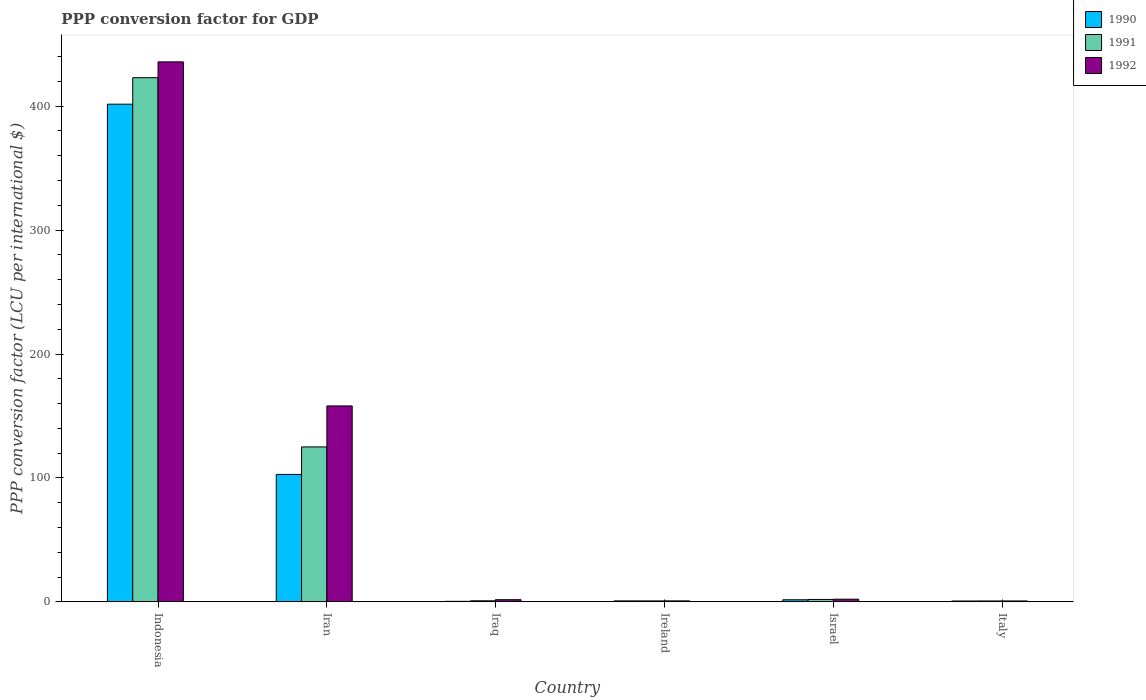How many different coloured bars are there?
Give a very brief answer. 3. How many groups of bars are there?
Give a very brief answer. 6. Are the number of bars per tick equal to the number of legend labels?
Your response must be concise. Yes. How many bars are there on the 2nd tick from the left?
Offer a very short reply. 3. How many bars are there on the 3rd tick from the right?
Ensure brevity in your answer.  3. In how many cases, is the number of bars for a given country not equal to the number of legend labels?
Give a very brief answer. 0. What is the PPP conversion factor for GDP in 1992 in Indonesia?
Your answer should be very brief. 435.74. Across all countries, what is the maximum PPP conversion factor for GDP in 1990?
Offer a very short reply. 401.61. Across all countries, what is the minimum PPP conversion factor for GDP in 1990?
Make the answer very short. 0.43. In which country was the PPP conversion factor for GDP in 1990 maximum?
Your answer should be very brief. Indonesia. What is the total PPP conversion factor for GDP in 1991 in the graph?
Provide a short and direct response. 552.39. What is the difference between the PPP conversion factor for GDP in 1990 in Iran and that in Iraq?
Offer a terse response. 102.42. What is the difference between the PPP conversion factor for GDP in 1992 in Iran and the PPP conversion factor for GDP in 1990 in Italy?
Keep it short and to the point. 157.41. What is the average PPP conversion factor for GDP in 1990 per country?
Offer a terse response. 84.68. What is the difference between the PPP conversion factor for GDP of/in 1992 and PPP conversion factor for GDP of/in 1990 in Iran?
Keep it short and to the point. 55.27. In how many countries, is the PPP conversion factor for GDP in 1991 greater than 220 LCU?
Offer a terse response. 1. What is the ratio of the PPP conversion factor for GDP in 1991 in Indonesia to that in Italy?
Offer a very short reply. 578.65. Is the PPP conversion factor for GDP in 1990 in Iraq less than that in Ireland?
Keep it short and to the point. Yes. Is the difference between the PPP conversion factor for GDP in 1992 in Iran and Israel greater than the difference between the PPP conversion factor for GDP in 1990 in Iran and Israel?
Your answer should be compact. Yes. What is the difference between the highest and the second highest PPP conversion factor for GDP in 1990?
Offer a terse response. 399.92. What is the difference between the highest and the lowest PPP conversion factor for GDP in 1991?
Keep it short and to the point. 422.26. What does the 2nd bar from the left in Israel represents?
Provide a succinct answer. 1991. What does the 1st bar from the right in Italy represents?
Your answer should be very brief. 1992. How many bars are there?
Make the answer very short. 18. Are all the bars in the graph horizontal?
Your answer should be very brief. No. Are the values on the major ticks of Y-axis written in scientific E-notation?
Provide a short and direct response. No. Does the graph contain any zero values?
Ensure brevity in your answer.  No. How many legend labels are there?
Make the answer very short. 3. How are the legend labels stacked?
Your answer should be very brief. Vertical. What is the title of the graph?
Your answer should be compact. PPP conversion factor for GDP. What is the label or title of the X-axis?
Offer a terse response. Country. What is the label or title of the Y-axis?
Your answer should be compact. PPP conversion factor (LCU per international $). What is the PPP conversion factor (LCU per international $) of 1990 in Indonesia?
Provide a short and direct response. 401.61. What is the PPP conversion factor (LCU per international $) of 1991 in Indonesia?
Provide a succinct answer. 422.99. What is the PPP conversion factor (LCU per international $) of 1992 in Indonesia?
Provide a succinct answer. 435.74. What is the PPP conversion factor (LCU per international $) of 1990 in Iran?
Offer a terse response. 102.85. What is the PPP conversion factor (LCU per international $) in 1991 in Iran?
Your answer should be very brief. 125.03. What is the PPP conversion factor (LCU per international $) of 1992 in Iran?
Provide a short and direct response. 158.12. What is the PPP conversion factor (LCU per international $) in 1990 in Iraq?
Your answer should be very brief. 0.43. What is the PPP conversion factor (LCU per international $) of 1991 in Iraq?
Keep it short and to the point. 0.88. What is the PPP conversion factor (LCU per international $) of 1992 in Iraq?
Your answer should be very brief. 1.76. What is the PPP conversion factor (LCU per international $) in 1990 in Ireland?
Ensure brevity in your answer.  0.8. What is the PPP conversion factor (LCU per international $) in 1991 in Ireland?
Your answer should be compact. 0.79. What is the PPP conversion factor (LCU per international $) in 1992 in Ireland?
Your answer should be compact. 0.8. What is the PPP conversion factor (LCU per international $) of 1990 in Israel?
Your answer should be very brief. 1.69. What is the PPP conversion factor (LCU per international $) of 1991 in Israel?
Make the answer very short. 1.97. What is the PPP conversion factor (LCU per international $) in 1992 in Israel?
Keep it short and to the point. 2.15. What is the PPP conversion factor (LCU per international $) in 1990 in Italy?
Offer a terse response. 0.7. What is the PPP conversion factor (LCU per international $) in 1991 in Italy?
Keep it short and to the point. 0.73. What is the PPP conversion factor (LCU per international $) of 1992 in Italy?
Offer a terse response. 0.75. Across all countries, what is the maximum PPP conversion factor (LCU per international $) of 1990?
Provide a succinct answer. 401.61. Across all countries, what is the maximum PPP conversion factor (LCU per international $) of 1991?
Offer a very short reply. 422.99. Across all countries, what is the maximum PPP conversion factor (LCU per international $) of 1992?
Offer a terse response. 435.74. Across all countries, what is the minimum PPP conversion factor (LCU per international $) of 1990?
Provide a succinct answer. 0.43. Across all countries, what is the minimum PPP conversion factor (LCU per international $) of 1991?
Your response must be concise. 0.73. Across all countries, what is the minimum PPP conversion factor (LCU per international $) of 1992?
Offer a terse response. 0.75. What is the total PPP conversion factor (LCU per international $) in 1990 in the graph?
Give a very brief answer. 508.09. What is the total PPP conversion factor (LCU per international $) of 1991 in the graph?
Ensure brevity in your answer.  552.39. What is the total PPP conversion factor (LCU per international $) in 1992 in the graph?
Give a very brief answer. 599.31. What is the difference between the PPP conversion factor (LCU per international $) in 1990 in Indonesia and that in Iran?
Your answer should be compact. 298.77. What is the difference between the PPP conversion factor (LCU per international $) in 1991 in Indonesia and that in Iran?
Your answer should be very brief. 297.95. What is the difference between the PPP conversion factor (LCU per international $) in 1992 in Indonesia and that in Iran?
Provide a succinct answer. 277.63. What is the difference between the PPP conversion factor (LCU per international $) in 1990 in Indonesia and that in Iraq?
Your answer should be compact. 401.18. What is the difference between the PPP conversion factor (LCU per international $) of 1991 in Indonesia and that in Iraq?
Provide a succinct answer. 422.11. What is the difference between the PPP conversion factor (LCU per international $) in 1992 in Indonesia and that in Iraq?
Give a very brief answer. 433.99. What is the difference between the PPP conversion factor (LCU per international $) in 1990 in Indonesia and that in Ireland?
Offer a very short reply. 400.81. What is the difference between the PPP conversion factor (LCU per international $) of 1991 in Indonesia and that in Ireland?
Provide a short and direct response. 422.19. What is the difference between the PPP conversion factor (LCU per international $) of 1992 in Indonesia and that in Ireland?
Offer a very short reply. 434.95. What is the difference between the PPP conversion factor (LCU per international $) in 1990 in Indonesia and that in Israel?
Provide a short and direct response. 399.92. What is the difference between the PPP conversion factor (LCU per international $) of 1991 in Indonesia and that in Israel?
Give a very brief answer. 421.02. What is the difference between the PPP conversion factor (LCU per international $) in 1992 in Indonesia and that in Israel?
Give a very brief answer. 433.59. What is the difference between the PPP conversion factor (LCU per international $) of 1990 in Indonesia and that in Italy?
Offer a very short reply. 400.91. What is the difference between the PPP conversion factor (LCU per international $) of 1991 in Indonesia and that in Italy?
Provide a short and direct response. 422.26. What is the difference between the PPP conversion factor (LCU per international $) of 1992 in Indonesia and that in Italy?
Your answer should be very brief. 435. What is the difference between the PPP conversion factor (LCU per international $) in 1990 in Iran and that in Iraq?
Offer a very short reply. 102.42. What is the difference between the PPP conversion factor (LCU per international $) in 1991 in Iran and that in Iraq?
Offer a very short reply. 124.15. What is the difference between the PPP conversion factor (LCU per international $) of 1992 in Iran and that in Iraq?
Your answer should be very brief. 156.36. What is the difference between the PPP conversion factor (LCU per international $) of 1990 in Iran and that in Ireland?
Your answer should be compact. 102.04. What is the difference between the PPP conversion factor (LCU per international $) of 1991 in Iran and that in Ireland?
Provide a succinct answer. 124.24. What is the difference between the PPP conversion factor (LCU per international $) in 1992 in Iran and that in Ireland?
Ensure brevity in your answer.  157.32. What is the difference between the PPP conversion factor (LCU per international $) in 1990 in Iran and that in Israel?
Your answer should be compact. 101.16. What is the difference between the PPP conversion factor (LCU per international $) of 1991 in Iran and that in Israel?
Give a very brief answer. 123.07. What is the difference between the PPP conversion factor (LCU per international $) in 1992 in Iran and that in Israel?
Make the answer very short. 155.96. What is the difference between the PPP conversion factor (LCU per international $) in 1990 in Iran and that in Italy?
Make the answer very short. 102.15. What is the difference between the PPP conversion factor (LCU per international $) in 1991 in Iran and that in Italy?
Offer a terse response. 124.3. What is the difference between the PPP conversion factor (LCU per international $) in 1992 in Iran and that in Italy?
Offer a terse response. 157.37. What is the difference between the PPP conversion factor (LCU per international $) in 1990 in Iraq and that in Ireland?
Offer a very short reply. -0.37. What is the difference between the PPP conversion factor (LCU per international $) in 1991 in Iraq and that in Ireland?
Keep it short and to the point. 0.09. What is the difference between the PPP conversion factor (LCU per international $) of 1992 in Iraq and that in Ireland?
Provide a succinct answer. 0.96. What is the difference between the PPP conversion factor (LCU per international $) in 1990 in Iraq and that in Israel?
Keep it short and to the point. -1.26. What is the difference between the PPP conversion factor (LCU per international $) of 1991 in Iraq and that in Israel?
Provide a short and direct response. -1.09. What is the difference between the PPP conversion factor (LCU per international $) in 1992 in Iraq and that in Israel?
Ensure brevity in your answer.  -0.4. What is the difference between the PPP conversion factor (LCU per international $) of 1990 in Iraq and that in Italy?
Make the answer very short. -0.27. What is the difference between the PPP conversion factor (LCU per international $) of 1991 in Iraq and that in Italy?
Your answer should be very brief. 0.15. What is the difference between the PPP conversion factor (LCU per international $) in 1992 in Iraq and that in Italy?
Keep it short and to the point. 1.01. What is the difference between the PPP conversion factor (LCU per international $) of 1990 in Ireland and that in Israel?
Offer a very short reply. -0.89. What is the difference between the PPP conversion factor (LCU per international $) in 1991 in Ireland and that in Israel?
Keep it short and to the point. -1.17. What is the difference between the PPP conversion factor (LCU per international $) of 1992 in Ireland and that in Israel?
Provide a short and direct response. -1.36. What is the difference between the PPP conversion factor (LCU per international $) of 1990 in Ireland and that in Italy?
Offer a terse response. 0.1. What is the difference between the PPP conversion factor (LCU per international $) of 1991 in Ireland and that in Italy?
Keep it short and to the point. 0.06. What is the difference between the PPP conversion factor (LCU per international $) of 1992 in Ireland and that in Italy?
Provide a succinct answer. 0.05. What is the difference between the PPP conversion factor (LCU per international $) in 1990 in Israel and that in Italy?
Keep it short and to the point. 0.99. What is the difference between the PPP conversion factor (LCU per international $) of 1991 in Israel and that in Italy?
Provide a short and direct response. 1.23. What is the difference between the PPP conversion factor (LCU per international $) of 1992 in Israel and that in Italy?
Offer a very short reply. 1.41. What is the difference between the PPP conversion factor (LCU per international $) in 1990 in Indonesia and the PPP conversion factor (LCU per international $) in 1991 in Iran?
Keep it short and to the point. 276.58. What is the difference between the PPP conversion factor (LCU per international $) of 1990 in Indonesia and the PPP conversion factor (LCU per international $) of 1992 in Iran?
Your answer should be compact. 243.5. What is the difference between the PPP conversion factor (LCU per international $) in 1991 in Indonesia and the PPP conversion factor (LCU per international $) in 1992 in Iran?
Give a very brief answer. 264.87. What is the difference between the PPP conversion factor (LCU per international $) of 1990 in Indonesia and the PPP conversion factor (LCU per international $) of 1991 in Iraq?
Provide a short and direct response. 400.74. What is the difference between the PPP conversion factor (LCU per international $) of 1990 in Indonesia and the PPP conversion factor (LCU per international $) of 1992 in Iraq?
Offer a very short reply. 399.86. What is the difference between the PPP conversion factor (LCU per international $) in 1991 in Indonesia and the PPP conversion factor (LCU per international $) in 1992 in Iraq?
Offer a terse response. 421.23. What is the difference between the PPP conversion factor (LCU per international $) of 1990 in Indonesia and the PPP conversion factor (LCU per international $) of 1991 in Ireland?
Make the answer very short. 400.82. What is the difference between the PPP conversion factor (LCU per international $) in 1990 in Indonesia and the PPP conversion factor (LCU per international $) in 1992 in Ireland?
Provide a short and direct response. 400.82. What is the difference between the PPP conversion factor (LCU per international $) in 1991 in Indonesia and the PPP conversion factor (LCU per international $) in 1992 in Ireland?
Give a very brief answer. 422.19. What is the difference between the PPP conversion factor (LCU per international $) in 1990 in Indonesia and the PPP conversion factor (LCU per international $) in 1991 in Israel?
Your answer should be very brief. 399.65. What is the difference between the PPP conversion factor (LCU per international $) of 1990 in Indonesia and the PPP conversion factor (LCU per international $) of 1992 in Israel?
Your answer should be very brief. 399.46. What is the difference between the PPP conversion factor (LCU per international $) of 1991 in Indonesia and the PPP conversion factor (LCU per international $) of 1992 in Israel?
Your answer should be very brief. 420.83. What is the difference between the PPP conversion factor (LCU per international $) of 1990 in Indonesia and the PPP conversion factor (LCU per international $) of 1991 in Italy?
Your answer should be compact. 400.88. What is the difference between the PPP conversion factor (LCU per international $) of 1990 in Indonesia and the PPP conversion factor (LCU per international $) of 1992 in Italy?
Your response must be concise. 400.87. What is the difference between the PPP conversion factor (LCU per international $) of 1991 in Indonesia and the PPP conversion factor (LCU per international $) of 1992 in Italy?
Your answer should be compact. 422.24. What is the difference between the PPP conversion factor (LCU per international $) in 1990 in Iran and the PPP conversion factor (LCU per international $) in 1991 in Iraq?
Your answer should be compact. 101.97. What is the difference between the PPP conversion factor (LCU per international $) of 1990 in Iran and the PPP conversion factor (LCU per international $) of 1992 in Iraq?
Give a very brief answer. 101.09. What is the difference between the PPP conversion factor (LCU per international $) in 1991 in Iran and the PPP conversion factor (LCU per international $) in 1992 in Iraq?
Your answer should be very brief. 123.28. What is the difference between the PPP conversion factor (LCU per international $) of 1990 in Iran and the PPP conversion factor (LCU per international $) of 1991 in Ireland?
Your answer should be compact. 102.06. What is the difference between the PPP conversion factor (LCU per international $) in 1990 in Iran and the PPP conversion factor (LCU per international $) in 1992 in Ireland?
Provide a short and direct response. 102.05. What is the difference between the PPP conversion factor (LCU per international $) of 1991 in Iran and the PPP conversion factor (LCU per international $) of 1992 in Ireland?
Give a very brief answer. 124.24. What is the difference between the PPP conversion factor (LCU per international $) of 1990 in Iran and the PPP conversion factor (LCU per international $) of 1991 in Israel?
Offer a terse response. 100.88. What is the difference between the PPP conversion factor (LCU per international $) in 1990 in Iran and the PPP conversion factor (LCU per international $) in 1992 in Israel?
Your answer should be compact. 100.69. What is the difference between the PPP conversion factor (LCU per international $) of 1991 in Iran and the PPP conversion factor (LCU per international $) of 1992 in Israel?
Make the answer very short. 122.88. What is the difference between the PPP conversion factor (LCU per international $) in 1990 in Iran and the PPP conversion factor (LCU per international $) in 1991 in Italy?
Your answer should be very brief. 102.12. What is the difference between the PPP conversion factor (LCU per international $) of 1990 in Iran and the PPP conversion factor (LCU per international $) of 1992 in Italy?
Your answer should be compact. 102.1. What is the difference between the PPP conversion factor (LCU per international $) in 1991 in Iran and the PPP conversion factor (LCU per international $) in 1992 in Italy?
Provide a succinct answer. 124.29. What is the difference between the PPP conversion factor (LCU per international $) of 1990 in Iraq and the PPP conversion factor (LCU per international $) of 1991 in Ireland?
Your response must be concise. -0.36. What is the difference between the PPP conversion factor (LCU per international $) of 1990 in Iraq and the PPP conversion factor (LCU per international $) of 1992 in Ireland?
Keep it short and to the point. -0.37. What is the difference between the PPP conversion factor (LCU per international $) in 1991 in Iraq and the PPP conversion factor (LCU per international $) in 1992 in Ireland?
Your answer should be very brief. 0.08. What is the difference between the PPP conversion factor (LCU per international $) of 1990 in Iraq and the PPP conversion factor (LCU per international $) of 1991 in Israel?
Your answer should be very brief. -1.54. What is the difference between the PPP conversion factor (LCU per international $) of 1990 in Iraq and the PPP conversion factor (LCU per international $) of 1992 in Israel?
Your answer should be compact. -1.72. What is the difference between the PPP conversion factor (LCU per international $) of 1991 in Iraq and the PPP conversion factor (LCU per international $) of 1992 in Israel?
Offer a terse response. -1.27. What is the difference between the PPP conversion factor (LCU per international $) in 1990 in Iraq and the PPP conversion factor (LCU per international $) in 1991 in Italy?
Your answer should be compact. -0.3. What is the difference between the PPP conversion factor (LCU per international $) of 1990 in Iraq and the PPP conversion factor (LCU per international $) of 1992 in Italy?
Provide a short and direct response. -0.32. What is the difference between the PPP conversion factor (LCU per international $) of 1991 in Iraq and the PPP conversion factor (LCU per international $) of 1992 in Italy?
Your answer should be very brief. 0.13. What is the difference between the PPP conversion factor (LCU per international $) in 1990 in Ireland and the PPP conversion factor (LCU per international $) in 1991 in Israel?
Your response must be concise. -1.16. What is the difference between the PPP conversion factor (LCU per international $) in 1990 in Ireland and the PPP conversion factor (LCU per international $) in 1992 in Israel?
Provide a short and direct response. -1.35. What is the difference between the PPP conversion factor (LCU per international $) in 1991 in Ireland and the PPP conversion factor (LCU per international $) in 1992 in Israel?
Provide a succinct answer. -1.36. What is the difference between the PPP conversion factor (LCU per international $) of 1990 in Ireland and the PPP conversion factor (LCU per international $) of 1991 in Italy?
Give a very brief answer. 0.07. What is the difference between the PPP conversion factor (LCU per international $) of 1990 in Ireland and the PPP conversion factor (LCU per international $) of 1992 in Italy?
Your answer should be very brief. 0.06. What is the difference between the PPP conversion factor (LCU per international $) in 1991 in Ireland and the PPP conversion factor (LCU per international $) in 1992 in Italy?
Provide a succinct answer. 0.05. What is the difference between the PPP conversion factor (LCU per international $) of 1990 in Israel and the PPP conversion factor (LCU per international $) of 1991 in Italy?
Keep it short and to the point. 0.96. What is the difference between the PPP conversion factor (LCU per international $) of 1990 in Israel and the PPP conversion factor (LCU per international $) of 1992 in Italy?
Offer a terse response. 0.94. What is the difference between the PPP conversion factor (LCU per international $) of 1991 in Israel and the PPP conversion factor (LCU per international $) of 1992 in Italy?
Provide a short and direct response. 1.22. What is the average PPP conversion factor (LCU per international $) of 1990 per country?
Offer a terse response. 84.68. What is the average PPP conversion factor (LCU per international $) in 1991 per country?
Provide a succinct answer. 92.06. What is the average PPP conversion factor (LCU per international $) in 1992 per country?
Keep it short and to the point. 99.89. What is the difference between the PPP conversion factor (LCU per international $) of 1990 and PPP conversion factor (LCU per international $) of 1991 in Indonesia?
Your response must be concise. -21.37. What is the difference between the PPP conversion factor (LCU per international $) of 1990 and PPP conversion factor (LCU per international $) of 1992 in Indonesia?
Offer a terse response. -34.13. What is the difference between the PPP conversion factor (LCU per international $) in 1991 and PPP conversion factor (LCU per international $) in 1992 in Indonesia?
Your response must be concise. -12.76. What is the difference between the PPP conversion factor (LCU per international $) of 1990 and PPP conversion factor (LCU per international $) of 1991 in Iran?
Offer a terse response. -22.18. What is the difference between the PPP conversion factor (LCU per international $) of 1990 and PPP conversion factor (LCU per international $) of 1992 in Iran?
Make the answer very short. -55.27. What is the difference between the PPP conversion factor (LCU per international $) in 1991 and PPP conversion factor (LCU per international $) in 1992 in Iran?
Your answer should be compact. -33.08. What is the difference between the PPP conversion factor (LCU per international $) in 1990 and PPP conversion factor (LCU per international $) in 1991 in Iraq?
Provide a short and direct response. -0.45. What is the difference between the PPP conversion factor (LCU per international $) of 1990 and PPP conversion factor (LCU per international $) of 1992 in Iraq?
Make the answer very short. -1.33. What is the difference between the PPP conversion factor (LCU per international $) in 1991 and PPP conversion factor (LCU per international $) in 1992 in Iraq?
Keep it short and to the point. -0.88. What is the difference between the PPP conversion factor (LCU per international $) of 1990 and PPP conversion factor (LCU per international $) of 1991 in Ireland?
Ensure brevity in your answer.  0.01. What is the difference between the PPP conversion factor (LCU per international $) of 1990 and PPP conversion factor (LCU per international $) of 1992 in Ireland?
Ensure brevity in your answer.  0.01. What is the difference between the PPP conversion factor (LCU per international $) of 1991 and PPP conversion factor (LCU per international $) of 1992 in Ireland?
Make the answer very short. -0. What is the difference between the PPP conversion factor (LCU per international $) in 1990 and PPP conversion factor (LCU per international $) in 1991 in Israel?
Offer a terse response. -0.27. What is the difference between the PPP conversion factor (LCU per international $) of 1990 and PPP conversion factor (LCU per international $) of 1992 in Israel?
Make the answer very short. -0.46. What is the difference between the PPP conversion factor (LCU per international $) in 1991 and PPP conversion factor (LCU per international $) in 1992 in Israel?
Offer a terse response. -0.19. What is the difference between the PPP conversion factor (LCU per international $) in 1990 and PPP conversion factor (LCU per international $) in 1991 in Italy?
Offer a terse response. -0.03. What is the difference between the PPP conversion factor (LCU per international $) of 1990 and PPP conversion factor (LCU per international $) of 1992 in Italy?
Provide a succinct answer. -0.04. What is the difference between the PPP conversion factor (LCU per international $) in 1991 and PPP conversion factor (LCU per international $) in 1992 in Italy?
Your answer should be very brief. -0.01. What is the ratio of the PPP conversion factor (LCU per international $) in 1990 in Indonesia to that in Iran?
Provide a short and direct response. 3.9. What is the ratio of the PPP conversion factor (LCU per international $) of 1991 in Indonesia to that in Iran?
Your answer should be very brief. 3.38. What is the ratio of the PPP conversion factor (LCU per international $) in 1992 in Indonesia to that in Iran?
Give a very brief answer. 2.76. What is the ratio of the PPP conversion factor (LCU per international $) in 1990 in Indonesia to that in Iraq?
Offer a terse response. 934.18. What is the ratio of the PPP conversion factor (LCU per international $) of 1991 in Indonesia to that in Iraq?
Ensure brevity in your answer.  481.54. What is the ratio of the PPP conversion factor (LCU per international $) of 1992 in Indonesia to that in Iraq?
Ensure brevity in your answer.  248.1. What is the ratio of the PPP conversion factor (LCU per international $) in 1990 in Indonesia to that in Ireland?
Make the answer very short. 499.04. What is the ratio of the PPP conversion factor (LCU per international $) in 1991 in Indonesia to that in Ireland?
Your response must be concise. 533.49. What is the ratio of the PPP conversion factor (LCU per international $) in 1992 in Indonesia to that in Ireland?
Give a very brief answer. 546.73. What is the ratio of the PPP conversion factor (LCU per international $) in 1990 in Indonesia to that in Israel?
Your answer should be very brief. 237.56. What is the ratio of the PPP conversion factor (LCU per international $) of 1991 in Indonesia to that in Israel?
Your answer should be compact. 215.21. What is the ratio of the PPP conversion factor (LCU per international $) of 1992 in Indonesia to that in Israel?
Your response must be concise. 202.35. What is the ratio of the PPP conversion factor (LCU per international $) of 1990 in Indonesia to that in Italy?
Provide a short and direct response. 572.02. What is the ratio of the PPP conversion factor (LCU per international $) of 1991 in Indonesia to that in Italy?
Offer a terse response. 578.65. What is the ratio of the PPP conversion factor (LCU per international $) in 1992 in Indonesia to that in Italy?
Your response must be concise. 584.17. What is the ratio of the PPP conversion factor (LCU per international $) in 1990 in Iran to that in Iraq?
Ensure brevity in your answer.  239.23. What is the ratio of the PPP conversion factor (LCU per international $) in 1991 in Iran to that in Iraq?
Ensure brevity in your answer.  142.34. What is the ratio of the PPP conversion factor (LCU per international $) of 1992 in Iran to that in Iraq?
Make the answer very short. 90.03. What is the ratio of the PPP conversion factor (LCU per international $) in 1990 in Iran to that in Ireland?
Your answer should be very brief. 127.8. What is the ratio of the PPP conversion factor (LCU per international $) in 1991 in Iran to that in Ireland?
Keep it short and to the point. 157.7. What is the ratio of the PPP conversion factor (LCU per international $) in 1992 in Iran to that in Ireland?
Offer a terse response. 198.39. What is the ratio of the PPP conversion factor (LCU per international $) of 1990 in Iran to that in Israel?
Your response must be concise. 60.84. What is the ratio of the PPP conversion factor (LCU per international $) in 1991 in Iran to that in Israel?
Ensure brevity in your answer.  63.61. What is the ratio of the PPP conversion factor (LCU per international $) of 1992 in Iran to that in Israel?
Offer a terse response. 73.43. What is the ratio of the PPP conversion factor (LCU per international $) in 1990 in Iran to that in Italy?
Your answer should be very brief. 146.49. What is the ratio of the PPP conversion factor (LCU per international $) of 1991 in Iran to that in Italy?
Provide a short and direct response. 171.05. What is the ratio of the PPP conversion factor (LCU per international $) of 1992 in Iran to that in Italy?
Give a very brief answer. 211.97. What is the ratio of the PPP conversion factor (LCU per international $) of 1990 in Iraq to that in Ireland?
Provide a short and direct response. 0.53. What is the ratio of the PPP conversion factor (LCU per international $) in 1991 in Iraq to that in Ireland?
Offer a very short reply. 1.11. What is the ratio of the PPP conversion factor (LCU per international $) in 1992 in Iraq to that in Ireland?
Provide a short and direct response. 2.2. What is the ratio of the PPP conversion factor (LCU per international $) of 1990 in Iraq to that in Israel?
Your response must be concise. 0.25. What is the ratio of the PPP conversion factor (LCU per international $) of 1991 in Iraq to that in Israel?
Your response must be concise. 0.45. What is the ratio of the PPP conversion factor (LCU per international $) in 1992 in Iraq to that in Israel?
Give a very brief answer. 0.82. What is the ratio of the PPP conversion factor (LCU per international $) in 1990 in Iraq to that in Italy?
Keep it short and to the point. 0.61. What is the ratio of the PPP conversion factor (LCU per international $) of 1991 in Iraq to that in Italy?
Ensure brevity in your answer.  1.2. What is the ratio of the PPP conversion factor (LCU per international $) in 1992 in Iraq to that in Italy?
Keep it short and to the point. 2.35. What is the ratio of the PPP conversion factor (LCU per international $) of 1990 in Ireland to that in Israel?
Give a very brief answer. 0.48. What is the ratio of the PPP conversion factor (LCU per international $) of 1991 in Ireland to that in Israel?
Make the answer very short. 0.4. What is the ratio of the PPP conversion factor (LCU per international $) of 1992 in Ireland to that in Israel?
Your answer should be compact. 0.37. What is the ratio of the PPP conversion factor (LCU per international $) in 1990 in Ireland to that in Italy?
Provide a short and direct response. 1.15. What is the ratio of the PPP conversion factor (LCU per international $) in 1991 in Ireland to that in Italy?
Your response must be concise. 1.08. What is the ratio of the PPP conversion factor (LCU per international $) in 1992 in Ireland to that in Italy?
Your answer should be compact. 1.07. What is the ratio of the PPP conversion factor (LCU per international $) of 1990 in Israel to that in Italy?
Give a very brief answer. 2.41. What is the ratio of the PPP conversion factor (LCU per international $) in 1991 in Israel to that in Italy?
Offer a very short reply. 2.69. What is the ratio of the PPP conversion factor (LCU per international $) of 1992 in Israel to that in Italy?
Make the answer very short. 2.89. What is the difference between the highest and the second highest PPP conversion factor (LCU per international $) of 1990?
Give a very brief answer. 298.77. What is the difference between the highest and the second highest PPP conversion factor (LCU per international $) of 1991?
Keep it short and to the point. 297.95. What is the difference between the highest and the second highest PPP conversion factor (LCU per international $) of 1992?
Keep it short and to the point. 277.63. What is the difference between the highest and the lowest PPP conversion factor (LCU per international $) in 1990?
Your response must be concise. 401.18. What is the difference between the highest and the lowest PPP conversion factor (LCU per international $) of 1991?
Provide a short and direct response. 422.26. What is the difference between the highest and the lowest PPP conversion factor (LCU per international $) in 1992?
Keep it short and to the point. 435. 